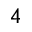Convert formula to latex. <formula><loc_0><loc_0><loc_500><loc_500>_ { 4 }</formula> 